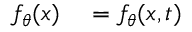Convert formula to latex. <formula><loc_0><loc_0><loc_500><loc_500>\begin{array} { r l } { f _ { \theta } ( x ) } & = f _ { \theta } ( x , t ) } \end{array}</formula> 